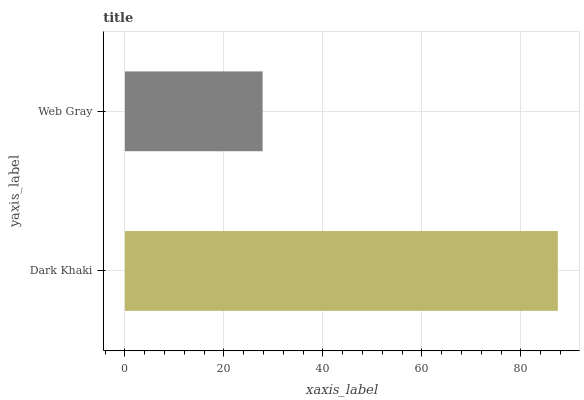Is Web Gray the minimum?
Answer yes or no. Yes. Is Dark Khaki the maximum?
Answer yes or no. Yes. Is Web Gray the maximum?
Answer yes or no. No. Is Dark Khaki greater than Web Gray?
Answer yes or no. Yes. Is Web Gray less than Dark Khaki?
Answer yes or no. Yes. Is Web Gray greater than Dark Khaki?
Answer yes or no. No. Is Dark Khaki less than Web Gray?
Answer yes or no. No. Is Dark Khaki the high median?
Answer yes or no. Yes. Is Web Gray the low median?
Answer yes or no. Yes. Is Web Gray the high median?
Answer yes or no. No. Is Dark Khaki the low median?
Answer yes or no. No. 